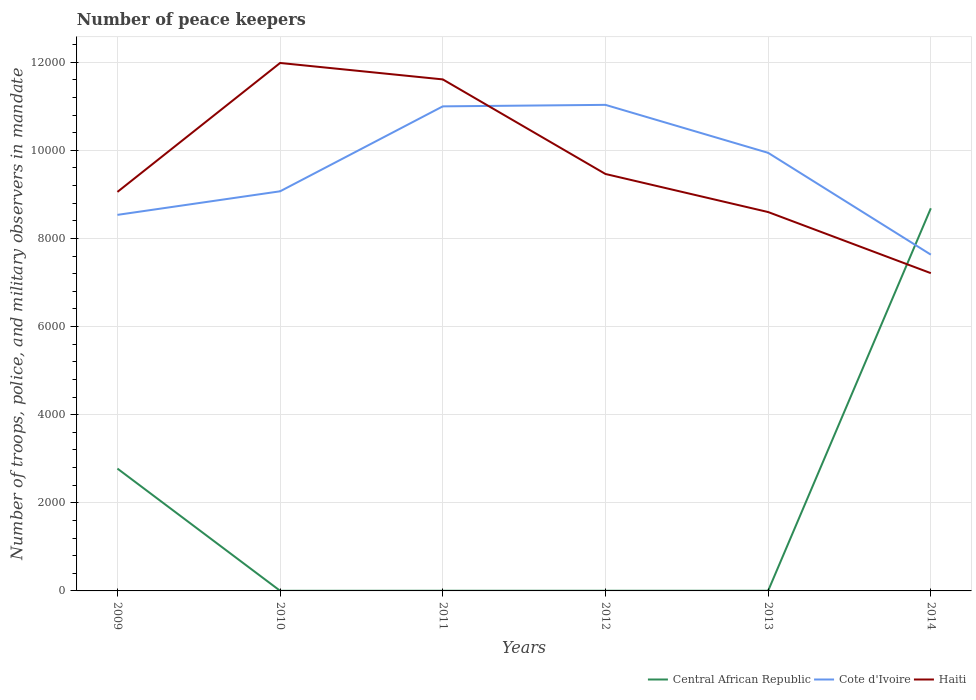Does the line corresponding to Central African Republic intersect with the line corresponding to Haiti?
Offer a very short reply. Yes. Across all years, what is the maximum number of peace keepers in in Haiti?
Keep it short and to the point. 7213. In which year was the number of peace keepers in in Cote d'Ivoire maximum?
Provide a short and direct response. 2014. What is the total number of peace keepers in in Cote d'Ivoire in the graph?
Keep it short and to the point. -873. What is the difference between the highest and the second highest number of peace keepers in in Central African Republic?
Keep it short and to the point. 8682. Is the number of peace keepers in in Central African Republic strictly greater than the number of peace keepers in in Haiti over the years?
Keep it short and to the point. No. What is the difference between two consecutive major ticks on the Y-axis?
Give a very brief answer. 2000. Are the values on the major ticks of Y-axis written in scientific E-notation?
Offer a very short reply. No. Does the graph contain any zero values?
Keep it short and to the point. No. Does the graph contain grids?
Offer a very short reply. Yes. How many legend labels are there?
Your answer should be compact. 3. How are the legend labels stacked?
Your response must be concise. Horizontal. What is the title of the graph?
Keep it short and to the point. Number of peace keepers. What is the label or title of the Y-axis?
Your answer should be very brief. Number of troops, police, and military observers in mandate. What is the Number of troops, police, and military observers in mandate in Central African Republic in 2009?
Make the answer very short. 2777. What is the Number of troops, police, and military observers in mandate of Cote d'Ivoire in 2009?
Provide a succinct answer. 8536. What is the Number of troops, police, and military observers in mandate of Haiti in 2009?
Offer a very short reply. 9057. What is the Number of troops, police, and military observers in mandate in Central African Republic in 2010?
Give a very brief answer. 3. What is the Number of troops, police, and military observers in mandate in Cote d'Ivoire in 2010?
Offer a very short reply. 9071. What is the Number of troops, police, and military observers in mandate of Haiti in 2010?
Provide a short and direct response. 1.20e+04. What is the Number of troops, police, and military observers in mandate of Cote d'Ivoire in 2011?
Make the answer very short. 1.10e+04. What is the Number of troops, police, and military observers in mandate of Haiti in 2011?
Your answer should be very brief. 1.16e+04. What is the Number of troops, police, and military observers in mandate in Cote d'Ivoire in 2012?
Offer a very short reply. 1.10e+04. What is the Number of troops, police, and military observers in mandate in Haiti in 2012?
Offer a terse response. 9464. What is the Number of troops, police, and military observers in mandate in Cote d'Ivoire in 2013?
Your answer should be very brief. 9944. What is the Number of troops, police, and military observers in mandate of Haiti in 2013?
Offer a terse response. 8600. What is the Number of troops, police, and military observers in mandate of Central African Republic in 2014?
Your answer should be very brief. 8685. What is the Number of troops, police, and military observers in mandate of Cote d'Ivoire in 2014?
Your response must be concise. 7633. What is the Number of troops, police, and military observers in mandate of Haiti in 2014?
Give a very brief answer. 7213. Across all years, what is the maximum Number of troops, police, and military observers in mandate of Central African Republic?
Make the answer very short. 8685. Across all years, what is the maximum Number of troops, police, and military observers in mandate in Cote d'Ivoire?
Give a very brief answer. 1.10e+04. Across all years, what is the maximum Number of troops, police, and military observers in mandate in Haiti?
Keep it short and to the point. 1.20e+04. Across all years, what is the minimum Number of troops, police, and military observers in mandate of Cote d'Ivoire?
Provide a succinct answer. 7633. Across all years, what is the minimum Number of troops, police, and military observers in mandate of Haiti?
Offer a very short reply. 7213. What is the total Number of troops, police, and military observers in mandate in Central African Republic in the graph?
Make the answer very short. 1.15e+04. What is the total Number of troops, police, and military observers in mandate in Cote d'Ivoire in the graph?
Your answer should be compact. 5.72e+04. What is the total Number of troops, police, and military observers in mandate of Haiti in the graph?
Offer a terse response. 5.79e+04. What is the difference between the Number of troops, police, and military observers in mandate in Central African Republic in 2009 and that in 2010?
Offer a very short reply. 2774. What is the difference between the Number of troops, police, and military observers in mandate in Cote d'Ivoire in 2009 and that in 2010?
Keep it short and to the point. -535. What is the difference between the Number of troops, police, and military observers in mandate in Haiti in 2009 and that in 2010?
Ensure brevity in your answer.  -2927. What is the difference between the Number of troops, police, and military observers in mandate in Central African Republic in 2009 and that in 2011?
Provide a succinct answer. 2773. What is the difference between the Number of troops, police, and military observers in mandate of Cote d'Ivoire in 2009 and that in 2011?
Offer a very short reply. -2463. What is the difference between the Number of troops, police, and military observers in mandate in Haiti in 2009 and that in 2011?
Make the answer very short. -2554. What is the difference between the Number of troops, police, and military observers in mandate of Central African Republic in 2009 and that in 2012?
Make the answer very short. 2773. What is the difference between the Number of troops, police, and military observers in mandate in Cote d'Ivoire in 2009 and that in 2012?
Keep it short and to the point. -2497. What is the difference between the Number of troops, police, and military observers in mandate in Haiti in 2009 and that in 2012?
Your response must be concise. -407. What is the difference between the Number of troops, police, and military observers in mandate in Central African Republic in 2009 and that in 2013?
Provide a succinct answer. 2773. What is the difference between the Number of troops, police, and military observers in mandate of Cote d'Ivoire in 2009 and that in 2013?
Provide a succinct answer. -1408. What is the difference between the Number of troops, police, and military observers in mandate of Haiti in 2009 and that in 2013?
Your response must be concise. 457. What is the difference between the Number of troops, police, and military observers in mandate in Central African Republic in 2009 and that in 2014?
Give a very brief answer. -5908. What is the difference between the Number of troops, police, and military observers in mandate of Cote d'Ivoire in 2009 and that in 2014?
Offer a terse response. 903. What is the difference between the Number of troops, police, and military observers in mandate in Haiti in 2009 and that in 2014?
Your answer should be compact. 1844. What is the difference between the Number of troops, police, and military observers in mandate in Cote d'Ivoire in 2010 and that in 2011?
Keep it short and to the point. -1928. What is the difference between the Number of troops, police, and military observers in mandate in Haiti in 2010 and that in 2011?
Your response must be concise. 373. What is the difference between the Number of troops, police, and military observers in mandate in Central African Republic in 2010 and that in 2012?
Provide a short and direct response. -1. What is the difference between the Number of troops, police, and military observers in mandate of Cote d'Ivoire in 2010 and that in 2012?
Keep it short and to the point. -1962. What is the difference between the Number of troops, police, and military observers in mandate of Haiti in 2010 and that in 2012?
Ensure brevity in your answer.  2520. What is the difference between the Number of troops, police, and military observers in mandate of Cote d'Ivoire in 2010 and that in 2013?
Make the answer very short. -873. What is the difference between the Number of troops, police, and military observers in mandate of Haiti in 2010 and that in 2013?
Your answer should be compact. 3384. What is the difference between the Number of troops, police, and military observers in mandate of Central African Republic in 2010 and that in 2014?
Ensure brevity in your answer.  -8682. What is the difference between the Number of troops, police, and military observers in mandate of Cote d'Ivoire in 2010 and that in 2014?
Ensure brevity in your answer.  1438. What is the difference between the Number of troops, police, and military observers in mandate in Haiti in 2010 and that in 2014?
Provide a succinct answer. 4771. What is the difference between the Number of troops, police, and military observers in mandate of Cote d'Ivoire in 2011 and that in 2012?
Ensure brevity in your answer.  -34. What is the difference between the Number of troops, police, and military observers in mandate in Haiti in 2011 and that in 2012?
Offer a terse response. 2147. What is the difference between the Number of troops, police, and military observers in mandate in Central African Republic in 2011 and that in 2013?
Provide a succinct answer. 0. What is the difference between the Number of troops, police, and military observers in mandate in Cote d'Ivoire in 2011 and that in 2013?
Offer a terse response. 1055. What is the difference between the Number of troops, police, and military observers in mandate in Haiti in 2011 and that in 2013?
Ensure brevity in your answer.  3011. What is the difference between the Number of troops, police, and military observers in mandate in Central African Republic in 2011 and that in 2014?
Give a very brief answer. -8681. What is the difference between the Number of troops, police, and military observers in mandate of Cote d'Ivoire in 2011 and that in 2014?
Offer a terse response. 3366. What is the difference between the Number of troops, police, and military observers in mandate of Haiti in 2011 and that in 2014?
Provide a succinct answer. 4398. What is the difference between the Number of troops, police, and military observers in mandate of Cote d'Ivoire in 2012 and that in 2013?
Offer a terse response. 1089. What is the difference between the Number of troops, police, and military observers in mandate of Haiti in 2012 and that in 2013?
Give a very brief answer. 864. What is the difference between the Number of troops, police, and military observers in mandate in Central African Republic in 2012 and that in 2014?
Give a very brief answer. -8681. What is the difference between the Number of troops, police, and military observers in mandate of Cote d'Ivoire in 2012 and that in 2014?
Your response must be concise. 3400. What is the difference between the Number of troops, police, and military observers in mandate of Haiti in 2012 and that in 2014?
Keep it short and to the point. 2251. What is the difference between the Number of troops, police, and military observers in mandate in Central African Republic in 2013 and that in 2014?
Keep it short and to the point. -8681. What is the difference between the Number of troops, police, and military observers in mandate in Cote d'Ivoire in 2013 and that in 2014?
Provide a succinct answer. 2311. What is the difference between the Number of troops, police, and military observers in mandate in Haiti in 2013 and that in 2014?
Ensure brevity in your answer.  1387. What is the difference between the Number of troops, police, and military observers in mandate of Central African Republic in 2009 and the Number of troops, police, and military observers in mandate of Cote d'Ivoire in 2010?
Offer a very short reply. -6294. What is the difference between the Number of troops, police, and military observers in mandate in Central African Republic in 2009 and the Number of troops, police, and military observers in mandate in Haiti in 2010?
Ensure brevity in your answer.  -9207. What is the difference between the Number of troops, police, and military observers in mandate of Cote d'Ivoire in 2009 and the Number of troops, police, and military observers in mandate of Haiti in 2010?
Give a very brief answer. -3448. What is the difference between the Number of troops, police, and military observers in mandate of Central African Republic in 2009 and the Number of troops, police, and military observers in mandate of Cote d'Ivoire in 2011?
Your response must be concise. -8222. What is the difference between the Number of troops, police, and military observers in mandate in Central African Republic in 2009 and the Number of troops, police, and military observers in mandate in Haiti in 2011?
Make the answer very short. -8834. What is the difference between the Number of troops, police, and military observers in mandate of Cote d'Ivoire in 2009 and the Number of troops, police, and military observers in mandate of Haiti in 2011?
Give a very brief answer. -3075. What is the difference between the Number of troops, police, and military observers in mandate in Central African Republic in 2009 and the Number of troops, police, and military observers in mandate in Cote d'Ivoire in 2012?
Provide a short and direct response. -8256. What is the difference between the Number of troops, police, and military observers in mandate in Central African Republic in 2009 and the Number of troops, police, and military observers in mandate in Haiti in 2012?
Your answer should be compact. -6687. What is the difference between the Number of troops, police, and military observers in mandate of Cote d'Ivoire in 2009 and the Number of troops, police, and military observers in mandate of Haiti in 2012?
Your response must be concise. -928. What is the difference between the Number of troops, police, and military observers in mandate in Central African Republic in 2009 and the Number of troops, police, and military observers in mandate in Cote d'Ivoire in 2013?
Make the answer very short. -7167. What is the difference between the Number of troops, police, and military observers in mandate in Central African Republic in 2009 and the Number of troops, police, and military observers in mandate in Haiti in 2013?
Keep it short and to the point. -5823. What is the difference between the Number of troops, police, and military observers in mandate of Cote d'Ivoire in 2009 and the Number of troops, police, and military observers in mandate of Haiti in 2013?
Provide a succinct answer. -64. What is the difference between the Number of troops, police, and military observers in mandate of Central African Republic in 2009 and the Number of troops, police, and military observers in mandate of Cote d'Ivoire in 2014?
Ensure brevity in your answer.  -4856. What is the difference between the Number of troops, police, and military observers in mandate of Central African Republic in 2009 and the Number of troops, police, and military observers in mandate of Haiti in 2014?
Your answer should be compact. -4436. What is the difference between the Number of troops, police, and military observers in mandate of Cote d'Ivoire in 2009 and the Number of troops, police, and military observers in mandate of Haiti in 2014?
Ensure brevity in your answer.  1323. What is the difference between the Number of troops, police, and military observers in mandate in Central African Republic in 2010 and the Number of troops, police, and military observers in mandate in Cote d'Ivoire in 2011?
Provide a succinct answer. -1.10e+04. What is the difference between the Number of troops, police, and military observers in mandate in Central African Republic in 2010 and the Number of troops, police, and military observers in mandate in Haiti in 2011?
Your response must be concise. -1.16e+04. What is the difference between the Number of troops, police, and military observers in mandate in Cote d'Ivoire in 2010 and the Number of troops, police, and military observers in mandate in Haiti in 2011?
Make the answer very short. -2540. What is the difference between the Number of troops, police, and military observers in mandate in Central African Republic in 2010 and the Number of troops, police, and military observers in mandate in Cote d'Ivoire in 2012?
Your response must be concise. -1.10e+04. What is the difference between the Number of troops, police, and military observers in mandate of Central African Republic in 2010 and the Number of troops, police, and military observers in mandate of Haiti in 2012?
Ensure brevity in your answer.  -9461. What is the difference between the Number of troops, police, and military observers in mandate in Cote d'Ivoire in 2010 and the Number of troops, police, and military observers in mandate in Haiti in 2012?
Your answer should be compact. -393. What is the difference between the Number of troops, police, and military observers in mandate in Central African Republic in 2010 and the Number of troops, police, and military observers in mandate in Cote d'Ivoire in 2013?
Offer a terse response. -9941. What is the difference between the Number of troops, police, and military observers in mandate in Central African Republic in 2010 and the Number of troops, police, and military observers in mandate in Haiti in 2013?
Your answer should be very brief. -8597. What is the difference between the Number of troops, police, and military observers in mandate in Cote d'Ivoire in 2010 and the Number of troops, police, and military observers in mandate in Haiti in 2013?
Offer a very short reply. 471. What is the difference between the Number of troops, police, and military observers in mandate in Central African Republic in 2010 and the Number of troops, police, and military observers in mandate in Cote d'Ivoire in 2014?
Keep it short and to the point. -7630. What is the difference between the Number of troops, police, and military observers in mandate in Central African Republic in 2010 and the Number of troops, police, and military observers in mandate in Haiti in 2014?
Make the answer very short. -7210. What is the difference between the Number of troops, police, and military observers in mandate in Cote d'Ivoire in 2010 and the Number of troops, police, and military observers in mandate in Haiti in 2014?
Offer a terse response. 1858. What is the difference between the Number of troops, police, and military observers in mandate of Central African Republic in 2011 and the Number of troops, police, and military observers in mandate of Cote d'Ivoire in 2012?
Provide a succinct answer. -1.10e+04. What is the difference between the Number of troops, police, and military observers in mandate of Central African Republic in 2011 and the Number of troops, police, and military observers in mandate of Haiti in 2012?
Give a very brief answer. -9460. What is the difference between the Number of troops, police, and military observers in mandate in Cote d'Ivoire in 2011 and the Number of troops, police, and military observers in mandate in Haiti in 2012?
Offer a terse response. 1535. What is the difference between the Number of troops, police, and military observers in mandate in Central African Republic in 2011 and the Number of troops, police, and military observers in mandate in Cote d'Ivoire in 2013?
Provide a succinct answer. -9940. What is the difference between the Number of troops, police, and military observers in mandate of Central African Republic in 2011 and the Number of troops, police, and military observers in mandate of Haiti in 2013?
Offer a terse response. -8596. What is the difference between the Number of troops, police, and military observers in mandate in Cote d'Ivoire in 2011 and the Number of troops, police, and military observers in mandate in Haiti in 2013?
Offer a very short reply. 2399. What is the difference between the Number of troops, police, and military observers in mandate in Central African Republic in 2011 and the Number of troops, police, and military observers in mandate in Cote d'Ivoire in 2014?
Keep it short and to the point. -7629. What is the difference between the Number of troops, police, and military observers in mandate of Central African Republic in 2011 and the Number of troops, police, and military observers in mandate of Haiti in 2014?
Keep it short and to the point. -7209. What is the difference between the Number of troops, police, and military observers in mandate in Cote d'Ivoire in 2011 and the Number of troops, police, and military observers in mandate in Haiti in 2014?
Offer a very short reply. 3786. What is the difference between the Number of troops, police, and military observers in mandate in Central African Republic in 2012 and the Number of troops, police, and military observers in mandate in Cote d'Ivoire in 2013?
Keep it short and to the point. -9940. What is the difference between the Number of troops, police, and military observers in mandate of Central African Republic in 2012 and the Number of troops, police, and military observers in mandate of Haiti in 2013?
Offer a very short reply. -8596. What is the difference between the Number of troops, police, and military observers in mandate of Cote d'Ivoire in 2012 and the Number of troops, police, and military observers in mandate of Haiti in 2013?
Your answer should be compact. 2433. What is the difference between the Number of troops, police, and military observers in mandate of Central African Republic in 2012 and the Number of troops, police, and military observers in mandate of Cote d'Ivoire in 2014?
Provide a short and direct response. -7629. What is the difference between the Number of troops, police, and military observers in mandate of Central African Republic in 2012 and the Number of troops, police, and military observers in mandate of Haiti in 2014?
Provide a short and direct response. -7209. What is the difference between the Number of troops, police, and military observers in mandate in Cote d'Ivoire in 2012 and the Number of troops, police, and military observers in mandate in Haiti in 2014?
Provide a short and direct response. 3820. What is the difference between the Number of troops, police, and military observers in mandate in Central African Republic in 2013 and the Number of troops, police, and military observers in mandate in Cote d'Ivoire in 2014?
Keep it short and to the point. -7629. What is the difference between the Number of troops, police, and military observers in mandate of Central African Republic in 2013 and the Number of troops, police, and military observers in mandate of Haiti in 2014?
Make the answer very short. -7209. What is the difference between the Number of troops, police, and military observers in mandate of Cote d'Ivoire in 2013 and the Number of troops, police, and military observers in mandate of Haiti in 2014?
Offer a very short reply. 2731. What is the average Number of troops, police, and military observers in mandate in Central African Republic per year?
Ensure brevity in your answer.  1912.83. What is the average Number of troops, police, and military observers in mandate of Cote d'Ivoire per year?
Keep it short and to the point. 9536. What is the average Number of troops, police, and military observers in mandate in Haiti per year?
Give a very brief answer. 9654.83. In the year 2009, what is the difference between the Number of troops, police, and military observers in mandate in Central African Republic and Number of troops, police, and military observers in mandate in Cote d'Ivoire?
Keep it short and to the point. -5759. In the year 2009, what is the difference between the Number of troops, police, and military observers in mandate of Central African Republic and Number of troops, police, and military observers in mandate of Haiti?
Your response must be concise. -6280. In the year 2009, what is the difference between the Number of troops, police, and military observers in mandate in Cote d'Ivoire and Number of troops, police, and military observers in mandate in Haiti?
Your answer should be very brief. -521. In the year 2010, what is the difference between the Number of troops, police, and military observers in mandate in Central African Republic and Number of troops, police, and military observers in mandate in Cote d'Ivoire?
Ensure brevity in your answer.  -9068. In the year 2010, what is the difference between the Number of troops, police, and military observers in mandate in Central African Republic and Number of troops, police, and military observers in mandate in Haiti?
Offer a very short reply. -1.20e+04. In the year 2010, what is the difference between the Number of troops, police, and military observers in mandate in Cote d'Ivoire and Number of troops, police, and military observers in mandate in Haiti?
Provide a succinct answer. -2913. In the year 2011, what is the difference between the Number of troops, police, and military observers in mandate of Central African Republic and Number of troops, police, and military observers in mandate of Cote d'Ivoire?
Offer a terse response. -1.10e+04. In the year 2011, what is the difference between the Number of troops, police, and military observers in mandate in Central African Republic and Number of troops, police, and military observers in mandate in Haiti?
Ensure brevity in your answer.  -1.16e+04. In the year 2011, what is the difference between the Number of troops, police, and military observers in mandate of Cote d'Ivoire and Number of troops, police, and military observers in mandate of Haiti?
Your answer should be very brief. -612. In the year 2012, what is the difference between the Number of troops, police, and military observers in mandate of Central African Republic and Number of troops, police, and military observers in mandate of Cote d'Ivoire?
Give a very brief answer. -1.10e+04. In the year 2012, what is the difference between the Number of troops, police, and military observers in mandate of Central African Republic and Number of troops, police, and military observers in mandate of Haiti?
Offer a very short reply. -9460. In the year 2012, what is the difference between the Number of troops, police, and military observers in mandate of Cote d'Ivoire and Number of troops, police, and military observers in mandate of Haiti?
Provide a succinct answer. 1569. In the year 2013, what is the difference between the Number of troops, police, and military observers in mandate in Central African Republic and Number of troops, police, and military observers in mandate in Cote d'Ivoire?
Provide a short and direct response. -9940. In the year 2013, what is the difference between the Number of troops, police, and military observers in mandate in Central African Republic and Number of troops, police, and military observers in mandate in Haiti?
Ensure brevity in your answer.  -8596. In the year 2013, what is the difference between the Number of troops, police, and military observers in mandate in Cote d'Ivoire and Number of troops, police, and military observers in mandate in Haiti?
Your answer should be very brief. 1344. In the year 2014, what is the difference between the Number of troops, police, and military observers in mandate in Central African Republic and Number of troops, police, and military observers in mandate in Cote d'Ivoire?
Keep it short and to the point. 1052. In the year 2014, what is the difference between the Number of troops, police, and military observers in mandate in Central African Republic and Number of troops, police, and military observers in mandate in Haiti?
Offer a terse response. 1472. In the year 2014, what is the difference between the Number of troops, police, and military observers in mandate in Cote d'Ivoire and Number of troops, police, and military observers in mandate in Haiti?
Provide a succinct answer. 420. What is the ratio of the Number of troops, police, and military observers in mandate of Central African Republic in 2009 to that in 2010?
Give a very brief answer. 925.67. What is the ratio of the Number of troops, police, and military observers in mandate in Cote d'Ivoire in 2009 to that in 2010?
Offer a terse response. 0.94. What is the ratio of the Number of troops, police, and military observers in mandate of Haiti in 2009 to that in 2010?
Offer a terse response. 0.76. What is the ratio of the Number of troops, police, and military observers in mandate in Central African Republic in 2009 to that in 2011?
Give a very brief answer. 694.25. What is the ratio of the Number of troops, police, and military observers in mandate in Cote d'Ivoire in 2009 to that in 2011?
Provide a short and direct response. 0.78. What is the ratio of the Number of troops, police, and military observers in mandate of Haiti in 2009 to that in 2011?
Offer a very short reply. 0.78. What is the ratio of the Number of troops, police, and military observers in mandate of Central African Republic in 2009 to that in 2012?
Give a very brief answer. 694.25. What is the ratio of the Number of troops, police, and military observers in mandate in Cote d'Ivoire in 2009 to that in 2012?
Make the answer very short. 0.77. What is the ratio of the Number of troops, police, and military observers in mandate of Central African Republic in 2009 to that in 2013?
Keep it short and to the point. 694.25. What is the ratio of the Number of troops, police, and military observers in mandate of Cote d'Ivoire in 2009 to that in 2013?
Provide a short and direct response. 0.86. What is the ratio of the Number of troops, police, and military observers in mandate in Haiti in 2009 to that in 2013?
Ensure brevity in your answer.  1.05. What is the ratio of the Number of troops, police, and military observers in mandate in Central African Republic in 2009 to that in 2014?
Keep it short and to the point. 0.32. What is the ratio of the Number of troops, police, and military observers in mandate of Cote d'Ivoire in 2009 to that in 2014?
Keep it short and to the point. 1.12. What is the ratio of the Number of troops, police, and military observers in mandate in Haiti in 2009 to that in 2014?
Give a very brief answer. 1.26. What is the ratio of the Number of troops, police, and military observers in mandate of Cote d'Ivoire in 2010 to that in 2011?
Offer a terse response. 0.82. What is the ratio of the Number of troops, police, and military observers in mandate of Haiti in 2010 to that in 2011?
Make the answer very short. 1.03. What is the ratio of the Number of troops, police, and military observers in mandate in Central African Republic in 2010 to that in 2012?
Your answer should be compact. 0.75. What is the ratio of the Number of troops, police, and military observers in mandate in Cote d'Ivoire in 2010 to that in 2012?
Offer a very short reply. 0.82. What is the ratio of the Number of troops, police, and military observers in mandate in Haiti in 2010 to that in 2012?
Offer a very short reply. 1.27. What is the ratio of the Number of troops, police, and military observers in mandate in Central African Republic in 2010 to that in 2013?
Offer a terse response. 0.75. What is the ratio of the Number of troops, police, and military observers in mandate in Cote d'Ivoire in 2010 to that in 2013?
Your answer should be very brief. 0.91. What is the ratio of the Number of troops, police, and military observers in mandate in Haiti in 2010 to that in 2013?
Your answer should be very brief. 1.39. What is the ratio of the Number of troops, police, and military observers in mandate of Cote d'Ivoire in 2010 to that in 2014?
Offer a very short reply. 1.19. What is the ratio of the Number of troops, police, and military observers in mandate in Haiti in 2010 to that in 2014?
Ensure brevity in your answer.  1.66. What is the ratio of the Number of troops, police, and military observers in mandate in Central African Republic in 2011 to that in 2012?
Provide a succinct answer. 1. What is the ratio of the Number of troops, police, and military observers in mandate in Haiti in 2011 to that in 2012?
Your response must be concise. 1.23. What is the ratio of the Number of troops, police, and military observers in mandate in Central African Republic in 2011 to that in 2013?
Offer a terse response. 1. What is the ratio of the Number of troops, police, and military observers in mandate in Cote d'Ivoire in 2011 to that in 2013?
Offer a very short reply. 1.11. What is the ratio of the Number of troops, police, and military observers in mandate of Haiti in 2011 to that in 2013?
Make the answer very short. 1.35. What is the ratio of the Number of troops, police, and military observers in mandate in Cote d'Ivoire in 2011 to that in 2014?
Give a very brief answer. 1.44. What is the ratio of the Number of troops, police, and military observers in mandate in Haiti in 2011 to that in 2014?
Keep it short and to the point. 1.61. What is the ratio of the Number of troops, police, and military observers in mandate in Central African Republic in 2012 to that in 2013?
Offer a terse response. 1. What is the ratio of the Number of troops, police, and military observers in mandate of Cote d'Ivoire in 2012 to that in 2013?
Ensure brevity in your answer.  1.11. What is the ratio of the Number of troops, police, and military observers in mandate in Haiti in 2012 to that in 2013?
Ensure brevity in your answer.  1.1. What is the ratio of the Number of troops, police, and military observers in mandate in Central African Republic in 2012 to that in 2014?
Provide a succinct answer. 0. What is the ratio of the Number of troops, police, and military observers in mandate in Cote d'Ivoire in 2012 to that in 2014?
Your response must be concise. 1.45. What is the ratio of the Number of troops, police, and military observers in mandate in Haiti in 2012 to that in 2014?
Your answer should be very brief. 1.31. What is the ratio of the Number of troops, police, and military observers in mandate of Central African Republic in 2013 to that in 2014?
Your answer should be compact. 0. What is the ratio of the Number of troops, police, and military observers in mandate of Cote d'Ivoire in 2013 to that in 2014?
Make the answer very short. 1.3. What is the ratio of the Number of troops, police, and military observers in mandate in Haiti in 2013 to that in 2014?
Provide a short and direct response. 1.19. What is the difference between the highest and the second highest Number of troops, police, and military observers in mandate in Central African Republic?
Provide a short and direct response. 5908. What is the difference between the highest and the second highest Number of troops, police, and military observers in mandate of Haiti?
Offer a very short reply. 373. What is the difference between the highest and the lowest Number of troops, police, and military observers in mandate of Central African Republic?
Provide a succinct answer. 8682. What is the difference between the highest and the lowest Number of troops, police, and military observers in mandate of Cote d'Ivoire?
Offer a terse response. 3400. What is the difference between the highest and the lowest Number of troops, police, and military observers in mandate in Haiti?
Make the answer very short. 4771. 